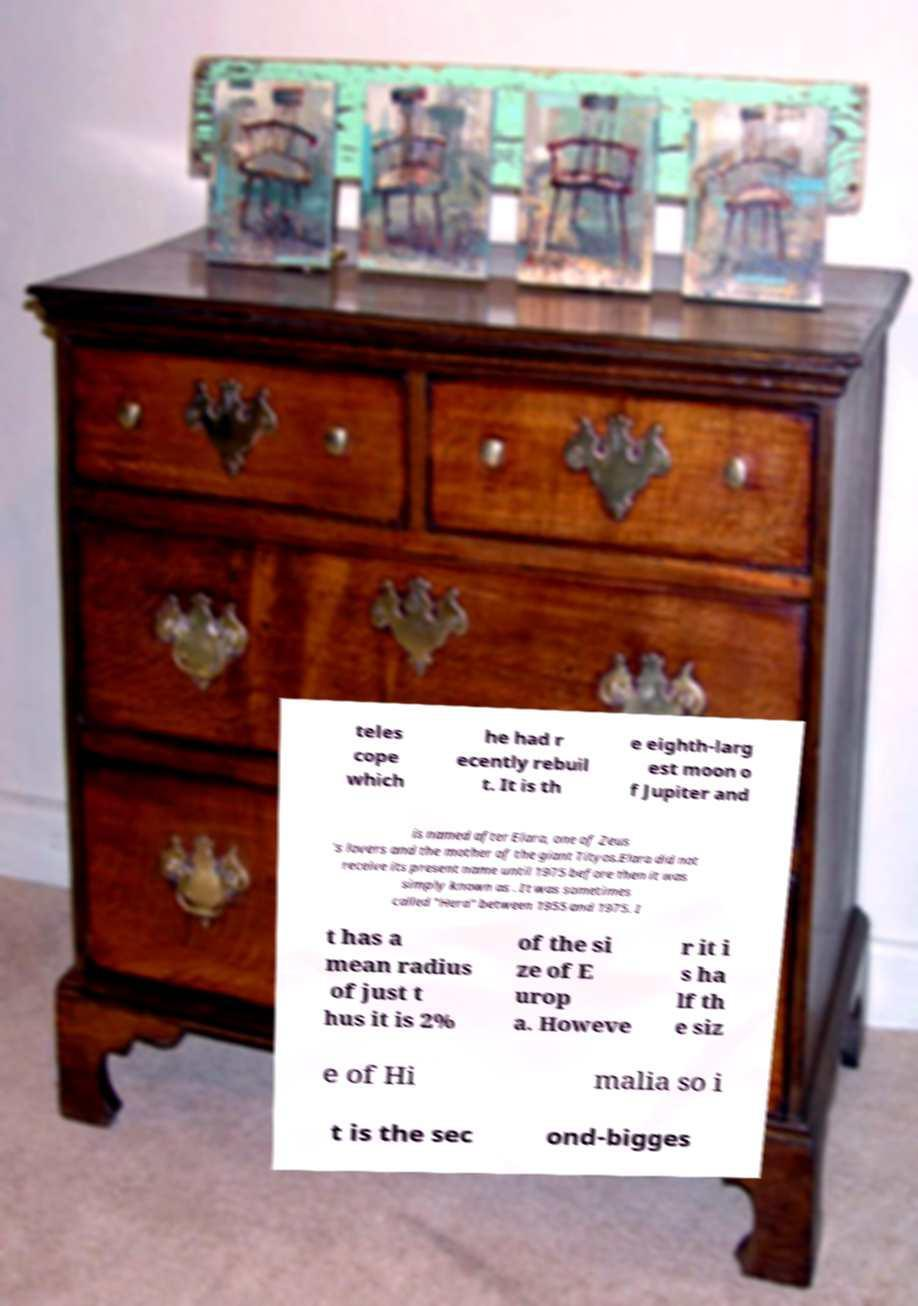Can you read and provide the text displayed in the image?This photo seems to have some interesting text. Can you extract and type it out for me? teles cope which he had r ecently rebuil t. It is th e eighth-larg est moon o f Jupiter and is named after Elara, one of Zeus 's lovers and the mother of the giant Tityos.Elara did not receive its present name until 1975 before then it was simply known as . It was sometimes called "Hera" between 1955 and 1975. I t has a mean radius of just t hus it is 2% of the si ze of E urop a. Howeve r it i s ha lf th e siz e of Hi malia so i t is the sec ond-bigges 